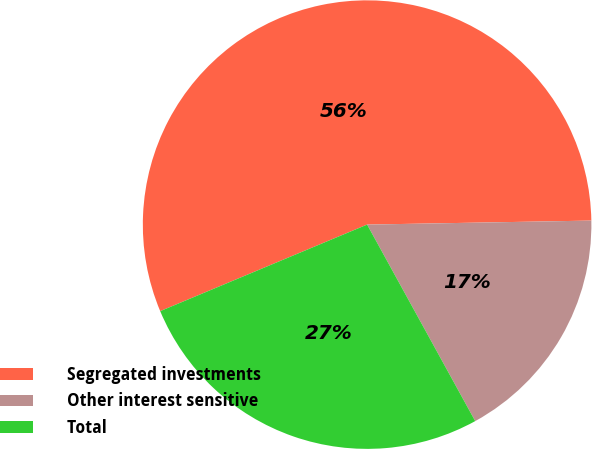Convert chart. <chart><loc_0><loc_0><loc_500><loc_500><pie_chart><fcel>Segregated investments<fcel>Other interest sensitive<fcel>Total<nl><fcel>56.02%<fcel>17.28%<fcel>26.7%<nl></chart> 